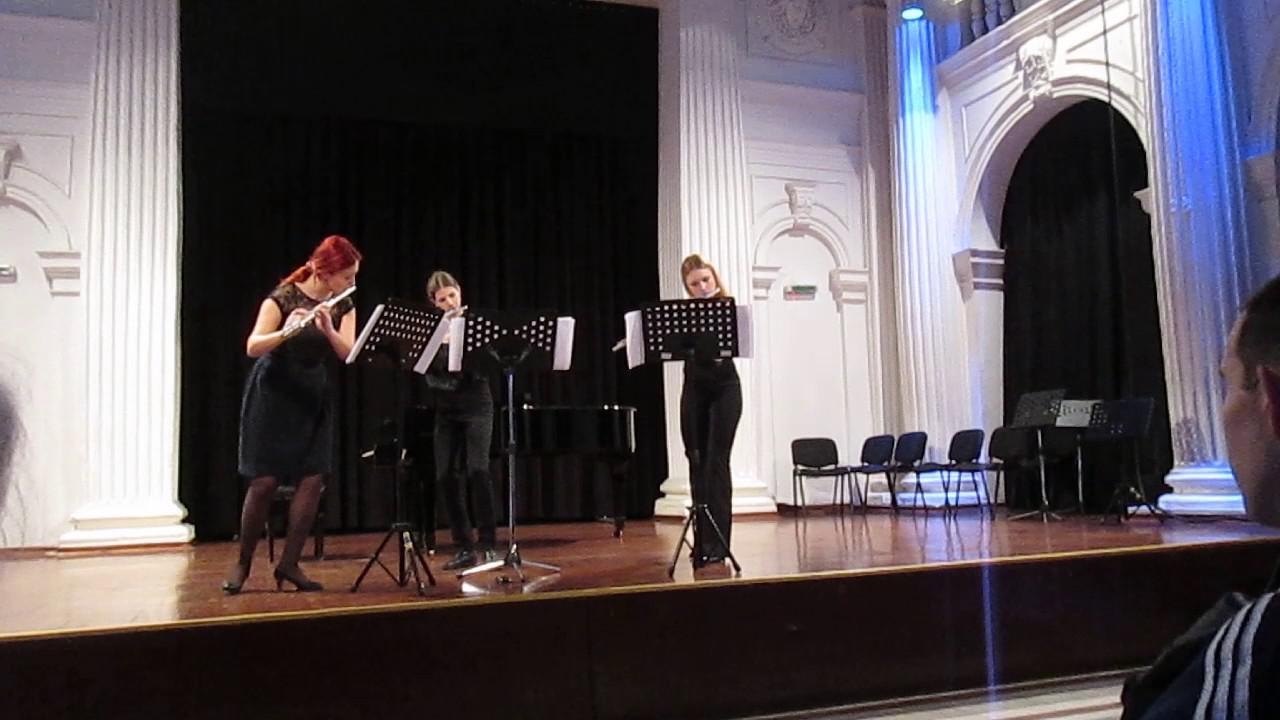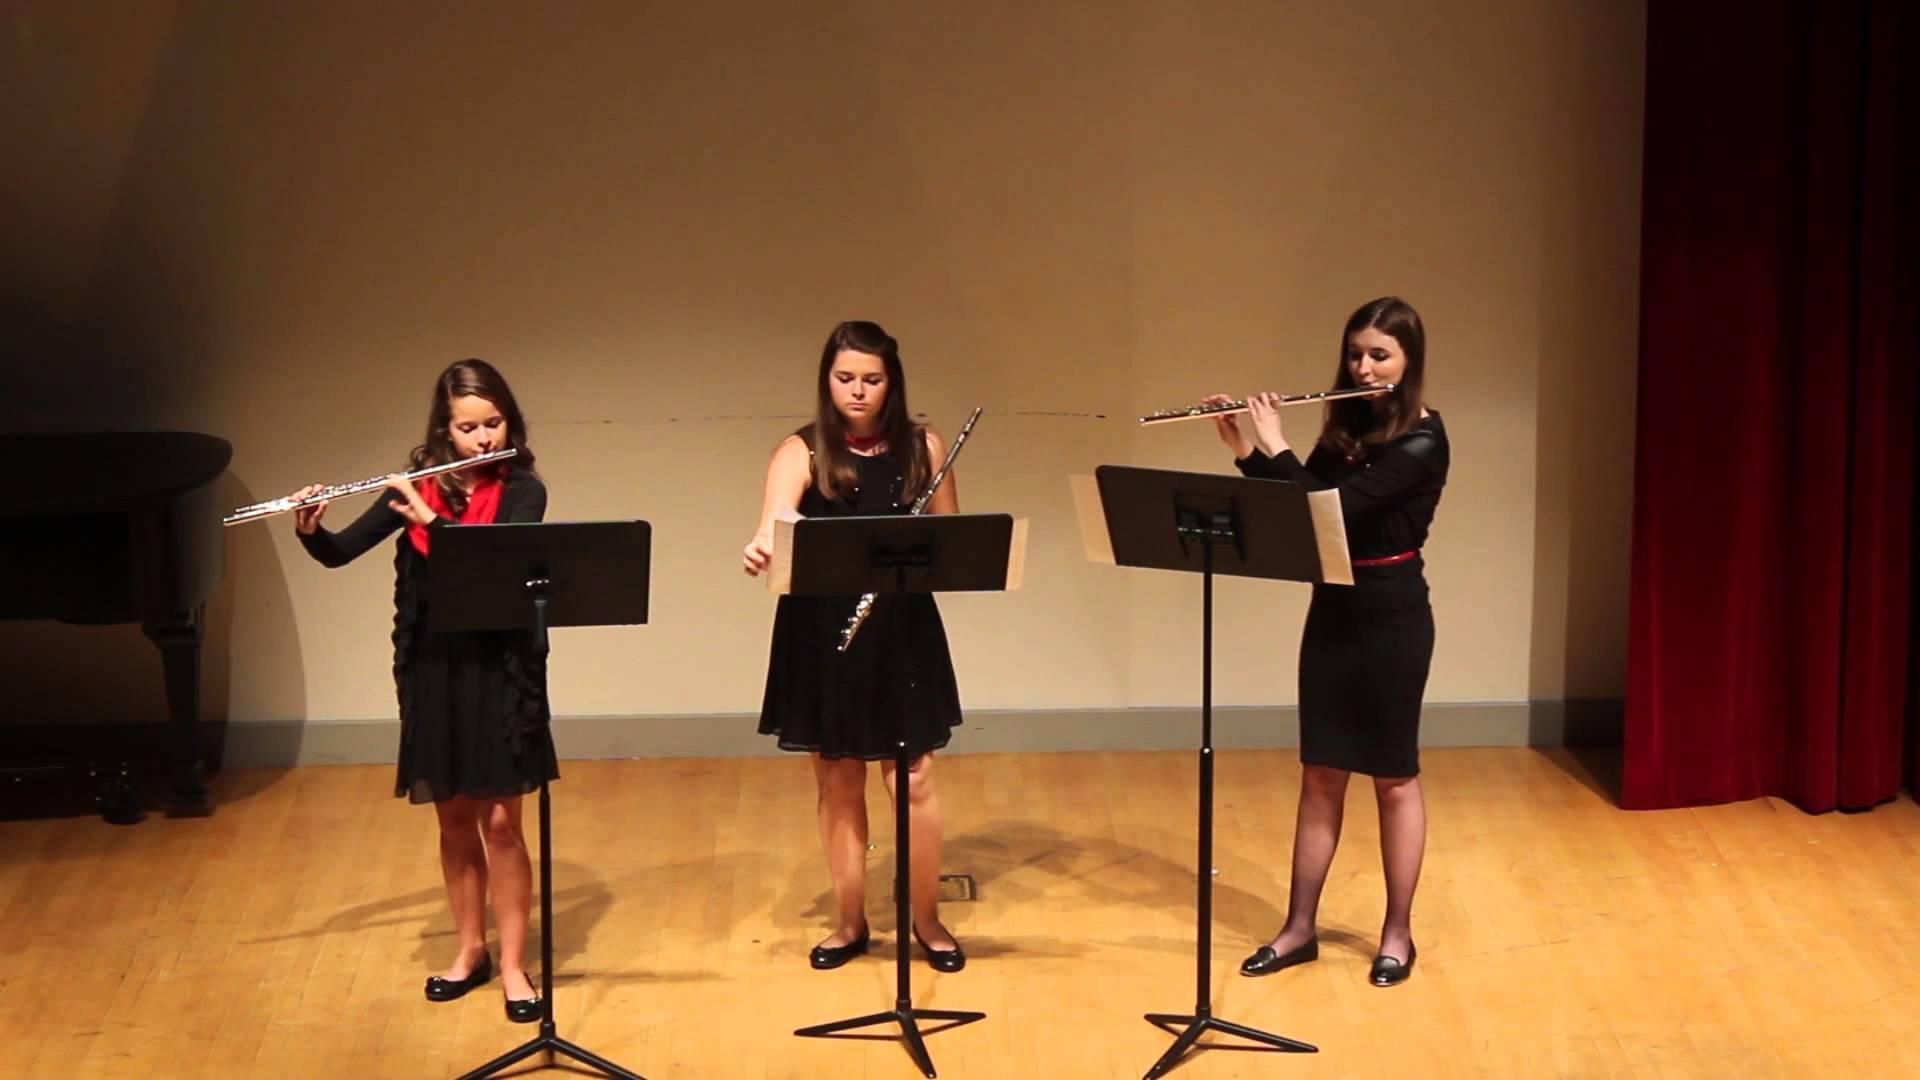The first image is the image on the left, the second image is the image on the right. Evaluate the accuracy of this statement regarding the images: "There are six flutists standing.". Is it true? Answer yes or no. Yes. 